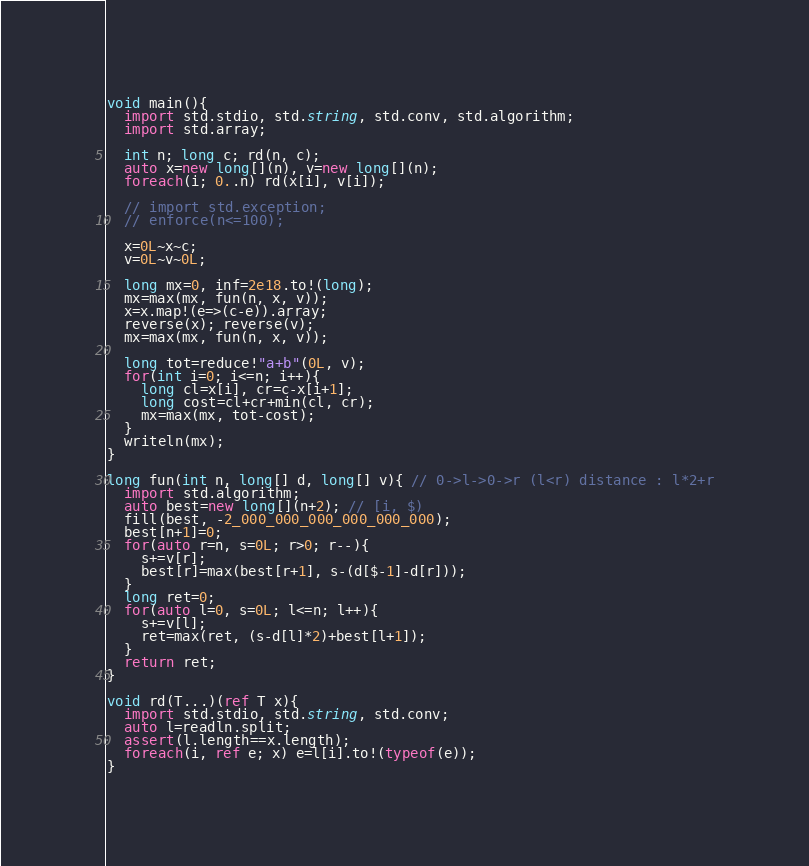<code> <loc_0><loc_0><loc_500><loc_500><_D_>void main(){
  import std.stdio, std.string, std.conv, std.algorithm;
  import std.array;
  
  int n; long c; rd(n, c);
  auto x=new long[](n), v=new long[](n);
  foreach(i; 0..n) rd(x[i], v[i]);

  // import std.exception;
  // enforce(n<=100);

  x=0L~x~c;
  v=0L~v~0L;

  long mx=0, inf=2e18.to!(long);
  mx=max(mx, fun(n, x, v));
  x=x.map!(e=>(c-e)).array;
  reverse(x); reverse(v);
  mx=max(mx, fun(n, x, v));

  long tot=reduce!"a+b"(0L, v);
  for(int i=0; i<=n; i++){
    long cl=x[i], cr=c-x[i+1];
    long cost=cl+cr+min(cl, cr);
    mx=max(mx, tot-cost);
  }
  writeln(mx);
}

long fun(int n, long[] d, long[] v){ // 0->l->0->r (l<r) distance : l*2+r
  import std.algorithm;
  auto best=new long[](n+2); // [i, $)
  fill(best, -2_000_000_000_000_000_000);
  best[n+1]=0;
  for(auto r=n, s=0L; r>0; r--){
    s+=v[r];
    best[r]=max(best[r+1], s-(d[$-1]-d[r]));
  }
  long ret=0;
  for(auto l=0, s=0L; l<=n; l++){
    s+=v[l];
    ret=max(ret, (s-d[l]*2)+best[l+1]);
  }
  return ret;
}

void rd(T...)(ref T x){
  import std.stdio, std.string, std.conv;
  auto l=readln.split;
  assert(l.length==x.length);
  foreach(i, ref e; x) e=l[i].to!(typeof(e));
}
</code> 